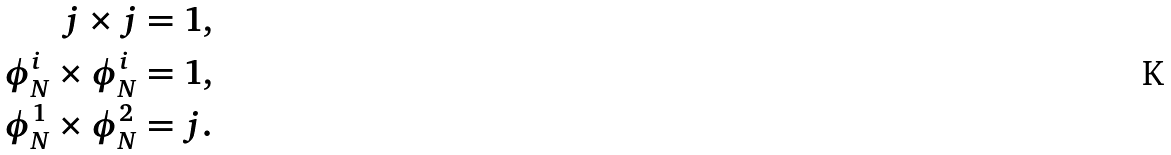Convert formula to latex. <formula><loc_0><loc_0><loc_500><loc_500>j \times j & = 1 , \\ \phi ^ { i } _ { N } \times \phi ^ { i } _ { N } & = 1 , \\ \phi ^ { 1 } _ { N } \times \phi _ { N } ^ { 2 } & = j .</formula> 